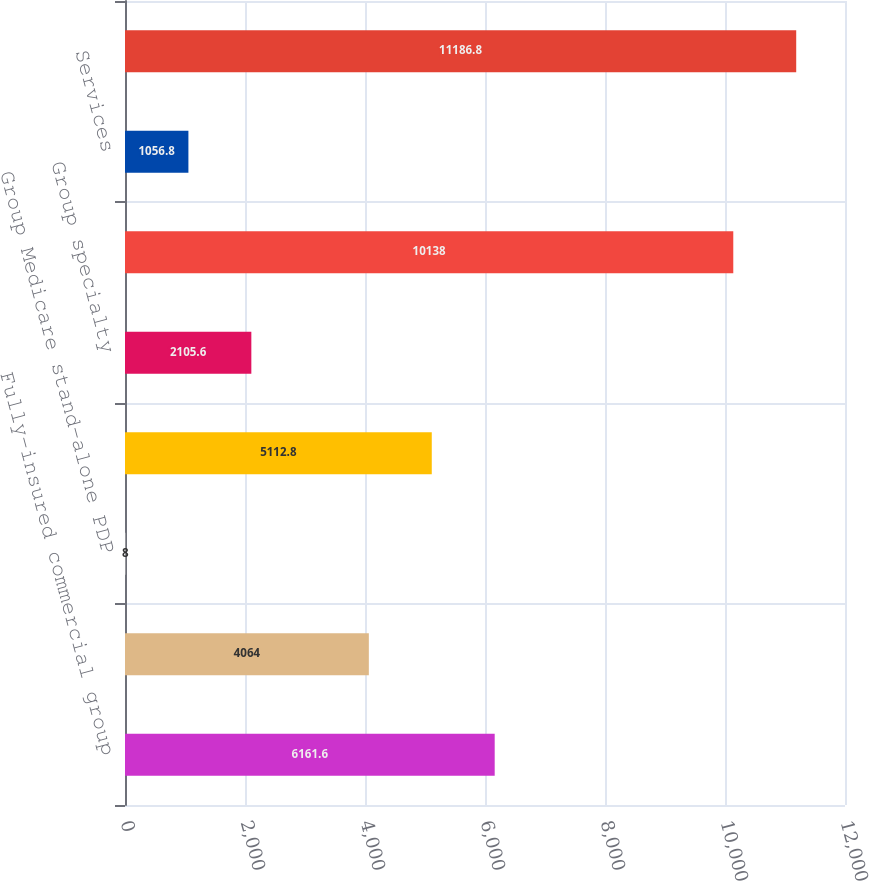<chart> <loc_0><loc_0><loc_500><loc_500><bar_chart><fcel>Fully-insured commercial group<fcel>Group Medicare Advantage<fcel>Group Medicare stand-alone PDP<fcel>Total group Medicare<fcel>Group specialty<fcel>Total premiums<fcel>Services<fcel>Total premiums and services<nl><fcel>6161.6<fcel>4064<fcel>8<fcel>5112.8<fcel>2105.6<fcel>10138<fcel>1056.8<fcel>11186.8<nl></chart> 